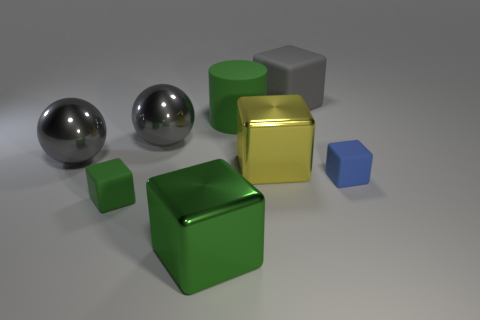Is there any other thing that is the same size as the matte cylinder?
Provide a succinct answer. Yes. There is a metallic cube that is behind the small matte cube to the right of the large gray cube; what size is it?
Your response must be concise. Large. The big matte cube has what color?
Offer a very short reply. Gray. How many metallic objects are left of the big cube that is behind the large green matte thing?
Your answer should be very brief. 4. Are there any large gray rubber things that are behind the block behind the large yellow block?
Your answer should be very brief. No. There is a small green matte thing; are there any big cylinders on the left side of it?
Your answer should be very brief. No. Does the green rubber thing in front of the green matte cylinder have the same shape as the large yellow shiny object?
Provide a succinct answer. Yes. How many green metal things have the same shape as the blue thing?
Give a very brief answer. 1. Is there a gray cube made of the same material as the cylinder?
Provide a short and direct response. Yes. There is a tiny object that is on the right side of the large green object in front of the big yellow metallic object; what is its material?
Keep it short and to the point. Rubber. 